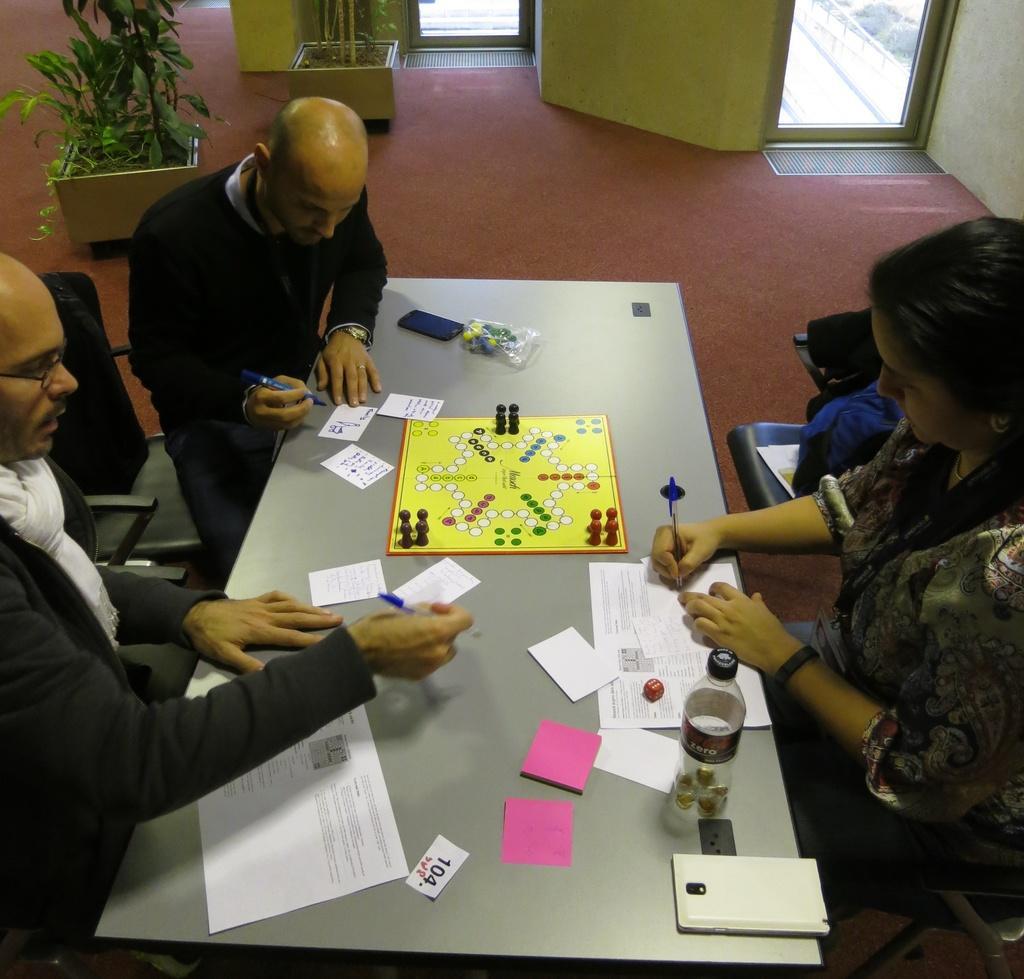Describe this image in one or two sentences. In this image we can see this three persons are sitting on the chairs around table. They are holding pens in their hand and writing something on the papers. In the background we can see a flower pot. 